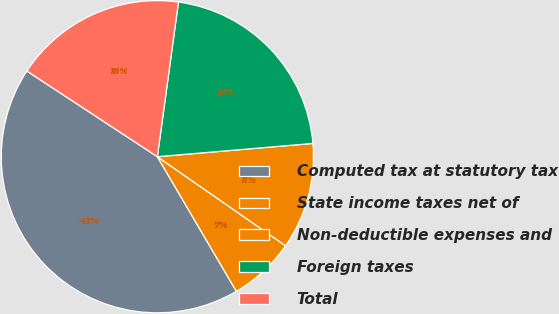Convert chart to OTSL. <chart><loc_0><loc_0><loc_500><loc_500><pie_chart><fcel>Computed tax at statutory tax<fcel>State income taxes net of<fcel>Non-deductible expenses and<fcel>Foreign taxes<fcel>Total<nl><fcel>42.7%<fcel>6.89%<fcel>11.02%<fcel>21.49%<fcel>17.91%<nl></chart> 